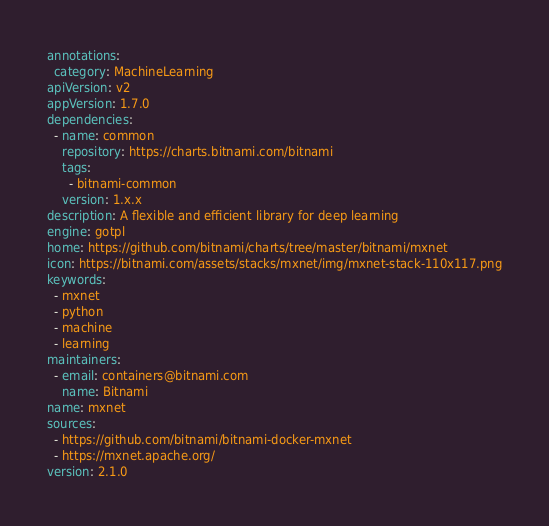Convert code to text. <code><loc_0><loc_0><loc_500><loc_500><_YAML_>annotations:
  category: MachineLearning
apiVersion: v2
appVersion: 1.7.0
dependencies:
  - name: common
    repository: https://charts.bitnami.com/bitnami
    tags:
      - bitnami-common
    version: 1.x.x
description: A flexible and efficient library for deep learning
engine: gotpl
home: https://github.com/bitnami/charts/tree/master/bitnami/mxnet
icon: https://bitnami.com/assets/stacks/mxnet/img/mxnet-stack-110x117.png
keywords:
  - mxnet
  - python
  - machine
  - learning
maintainers:
  - email: containers@bitnami.com
    name: Bitnami
name: mxnet
sources:
  - https://github.com/bitnami/bitnami-docker-mxnet
  - https://mxnet.apache.org/
version: 2.1.0
</code> 